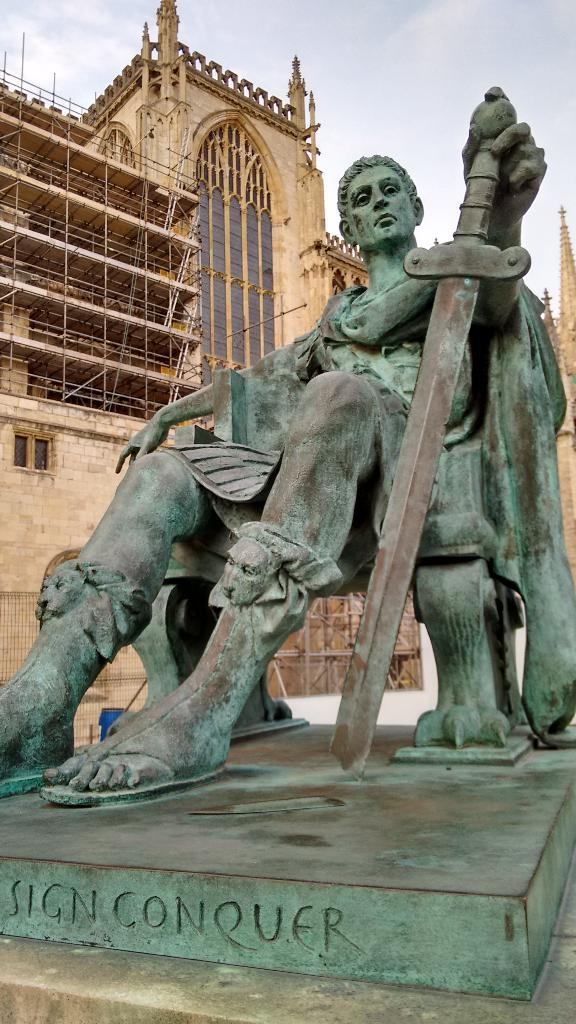What is the main subject in the image? There is a statue in the image. What other structure can be seen in the image? There is a building in the image. What can be seen in the background of the image? The sky is visible in the background of the image. What street is the actor walking down in the image? There is no street or actor present in the image; it features a statue and a building with a visible sky in the background. 